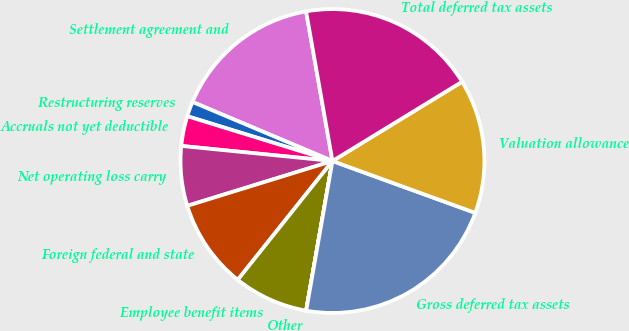Convert chart. <chart><loc_0><loc_0><loc_500><loc_500><pie_chart><fcel>Settlement agreement and<fcel>Restructuring reserves<fcel>Accruals not yet deductible<fcel>Net operating loss carry<fcel>Foreign federal and state<fcel>Employee benefit items<fcel>Other<fcel>Gross deferred tax assets<fcel>Valuation allowance<fcel>Total deferred tax assets<nl><fcel>15.87%<fcel>1.59%<fcel>3.18%<fcel>6.35%<fcel>9.52%<fcel>7.94%<fcel>0.01%<fcel>22.22%<fcel>14.28%<fcel>19.04%<nl></chart> 